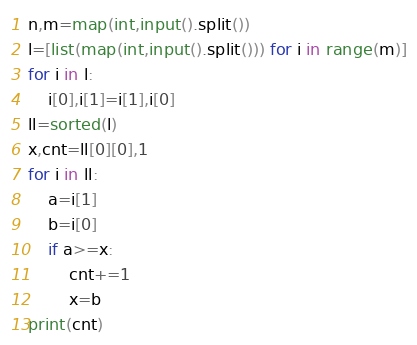Convert code to text. <code><loc_0><loc_0><loc_500><loc_500><_Python_>n,m=map(int,input().split())
l=[list(map(int,input().split())) for i in range(m)]
for i in l:
    i[0],i[1]=i[1],i[0]
ll=sorted(l)
x,cnt=ll[0][0],1
for i in ll:
    a=i[1]
    b=i[0]
    if a>=x:
        cnt+=1
        x=b
print(cnt)</code> 